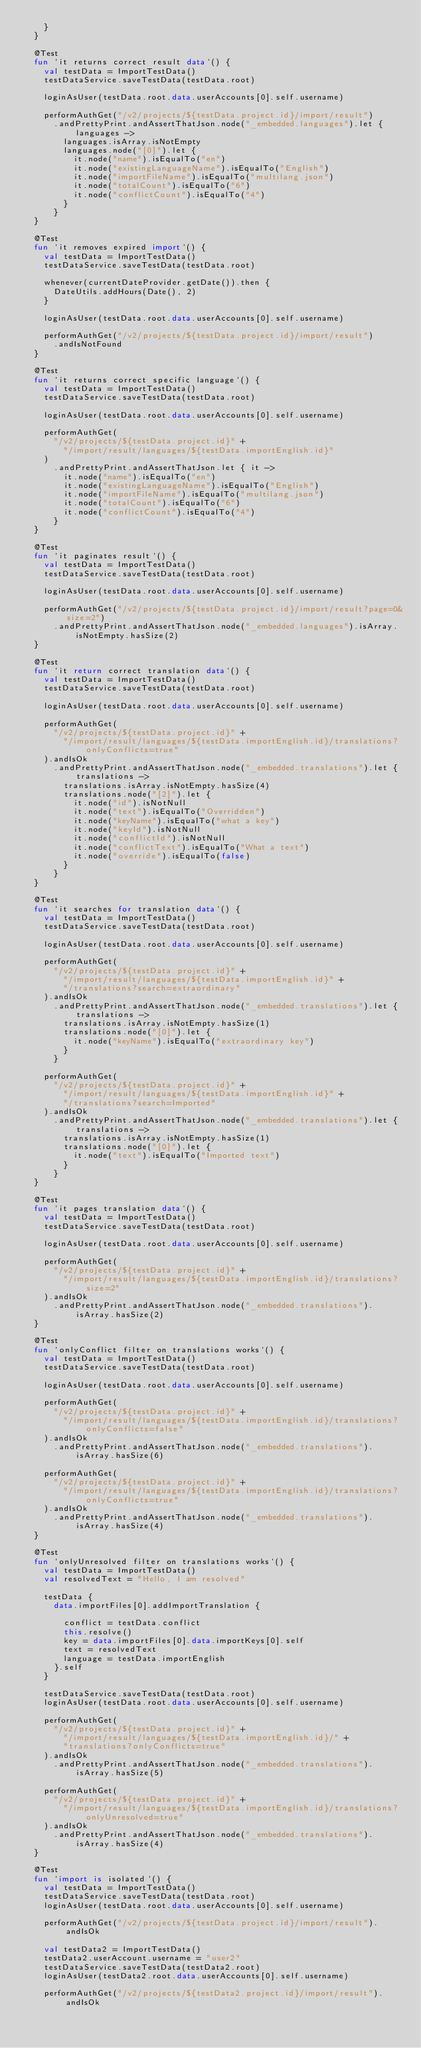Convert code to text. <code><loc_0><loc_0><loc_500><loc_500><_Kotlin_>    }
  }

  @Test
  fun `it returns correct result data`() {
    val testData = ImportTestData()
    testDataService.saveTestData(testData.root)

    loginAsUser(testData.root.data.userAccounts[0].self.username)

    performAuthGet("/v2/projects/${testData.project.id}/import/result")
      .andPrettyPrint.andAssertThatJson.node("_embedded.languages").let { languages ->
        languages.isArray.isNotEmpty
        languages.node("[0]").let {
          it.node("name").isEqualTo("en")
          it.node("existingLanguageName").isEqualTo("English")
          it.node("importFileName").isEqualTo("multilang.json")
          it.node("totalCount").isEqualTo("6")
          it.node("conflictCount").isEqualTo("4")
        }
      }
  }

  @Test
  fun `it removes expired import`() {
    val testData = ImportTestData()
    testDataService.saveTestData(testData.root)

    whenever(currentDateProvider.getDate()).then {
      DateUtils.addHours(Date(), 2)
    }

    loginAsUser(testData.root.data.userAccounts[0].self.username)

    performAuthGet("/v2/projects/${testData.project.id}/import/result")
      .andIsNotFound
  }

  @Test
  fun `it returns correct specific language`() {
    val testData = ImportTestData()
    testDataService.saveTestData(testData.root)

    loginAsUser(testData.root.data.userAccounts[0].self.username)

    performAuthGet(
      "/v2/projects/${testData.project.id}" +
        "/import/result/languages/${testData.importEnglish.id}"
    )
      .andPrettyPrint.andAssertThatJson.let { it ->
        it.node("name").isEqualTo("en")
        it.node("existingLanguageName").isEqualTo("English")
        it.node("importFileName").isEqualTo("multilang.json")
        it.node("totalCount").isEqualTo("6")
        it.node("conflictCount").isEqualTo("4")
      }
  }

  @Test
  fun `it paginates result`() {
    val testData = ImportTestData()
    testDataService.saveTestData(testData.root)

    loginAsUser(testData.root.data.userAccounts[0].self.username)

    performAuthGet("/v2/projects/${testData.project.id}/import/result?page=0&size=2")
      .andPrettyPrint.andAssertThatJson.node("_embedded.languages").isArray.isNotEmpty.hasSize(2)
  }

  @Test
  fun `it return correct translation data`() {
    val testData = ImportTestData()
    testDataService.saveTestData(testData.root)

    loginAsUser(testData.root.data.userAccounts[0].self.username)

    performAuthGet(
      "/v2/projects/${testData.project.id}" +
        "/import/result/languages/${testData.importEnglish.id}/translations?onlyConflicts=true"
    ).andIsOk
      .andPrettyPrint.andAssertThatJson.node("_embedded.translations").let { translations ->
        translations.isArray.isNotEmpty.hasSize(4)
        translations.node("[2]").let {
          it.node("id").isNotNull
          it.node("text").isEqualTo("Overridden")
          it.node("keyName").isEqualTo("what a key")
          it.node("keyId").isNotNull
          it.node("conflictId").isNotNull
          it.node("conflictText").isEqualTo("What a text")
          it.node("override").isEqualTo(false)
        }
      }
  }

  @Test
  fun `it searches for translation data`() {
    val testData = ImportTestData()
    testDataService.saveTestData(testData.root)

    loginAsUser(testData.root.data.userAccounts[0].self.username)

    performAuthGet(
      "/v2/projects/${testData.project.id}" +
        "/import/result/languages/${testData.importEnglish.id}" +
        "/translations?search=extraordinary"
    ).andIsOk
      .andPrettyPrint.andAssertThatJson.node("_embedded.translations").let { translations ->
        translations.isArray.isNotEmpty.hasSize(1)
        translations.node("[0]").let {
          it.node("keyName").isEqualTo("extraordinary key")
        }
      }

    performAuthGet(
      "/v2/projects/${testData.project.id}" +
        "/import/result/languages/${testData.importEnglish.id}" +
        "/translations?search=Imported"
    ).andIsOk
      .andPrettyPrint.andAssertThatJson.node("_embedded.translations").let { translations ->
        translations.isArray.isNotEmpty.hasSize(1)
        translations.node("[0]").let {
          it.node("text").isEqualTo("Imported text")
        }
      }
  }

  @Test
  fun `it pages translation data`() {
    val testData = ImportTestData()
    testDataService.saveTestData(testData.root)

    loginAsUser(testData.root.data.userAccounts[0].self.username)

    performAuthGet(
      "/v2/projects/${testData.project.id}" +
        "/import/result/languages/${testData.importEnglish.id}/translations?size=2"
    ).andIsOk
      .andPrettyPrint.andAssertThatJson.node("_embedded.translations").isArray.hasSize(2)
  }

  @Test
  fun `onlyConflict filter on translations works`() {
    val testData = ImportTestData()
    testDataService.saveTestData(testData.root)

    loginAsUser(testData.root.data.userAccounts[0].self.username)

    performAuthGet(
      "/v2/projects/${testData.project.id}" +
        "/import/result/languages/${testData.importEnglish.id}/translations?onlyConflicts=false"
    ).andIsOk
      .andPrettyPrint.andAssertThatJson.node("_embedded.translations").isArray.hasSize(6)

    performAuthGet(
      "/v2/projects/${testData.project.id}" +
        "/import/result/languages/${testData.importEnglish.id}/translations?onlyConflicts=true"
    ).andIsOk
      .andPrettyPrint.andAssertThatJson.node("_embedded.translations").isArray.hasSize(4)
  }

  @Test
  fun `onlyUnresolved filter on translations works`() {
    val testData = ImportTestData()
    val resolvedText = "Hello, I am resolved"

    testData {
      data.importFiles[0].addImportTranslation {

        conflict = testData.conflict
        this.resolve()
        key = data.importFiles[0].data.importKeys[0].self
        text = resolvedText
        language = testData.importEnglish
      }.self
    }

    testDataService.saveTestData(testData.root)
    loginAsUser(testData.root.data.userAccounts[0].self.username)

    performAuthGet(
      "/v2/projects/${testData.project.id}" +
        "/import/result/languages/${testData.importEnglish.id}/" +
        "translations?onlyConflicts=true"
    ).andIsOk
      .andPrettyPrint.andAssertThatJson.node("_embedded.translations").isArray.hasSize(5)

    performAuthGet(
      "/v2/projects/${testData.project.id}" +
        "/import/result/languages/${testData.importEnglish.id}/translations?onlyUnresolved=true"
    ).andIsOk
      .andPrettyPrint.andAssertThatJson.node("_embedded.translations").isArray.hasSize(4)
  }

  @Test
  fun `import is isolated`() {
    val testData = ImportTestData()
    testDataService.saveTestData(testData.root)
    loginAsUser(testData.root.data.userAccounts[0].self.username)

    performAuthGet("/v2/projects/${testData.project.id}/import/result").andIsOk

    val testData2 = ImportTestData()
    testData2.userAccount.username = "user2"
    testDataService.saveTestData(testData2.root)
    loginAsUser(testData2.root.data.userAccounts[0].self.username)

    performAuthGet("/v2/projects/${testData2.project.id}/import/result").andIsOk</code> 